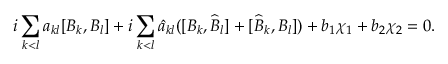<formula> <loc_0><loc_0><loc_500><loc_500>i \sum _ { k < l } a _ { k l } [ B _ { k } , B _ { l } ] + i \sum _ { k < l } \widehat { a } _ { k l } ( [ B _ { k } , \widehat { B } _ { l } ] + [ \widehat { B } _ { k } , B _ { l } ] ) + b _ { 1 } \chi _ { 1 } + b _ { 2 } \chi _ { 2 } = 0 .</formula> 